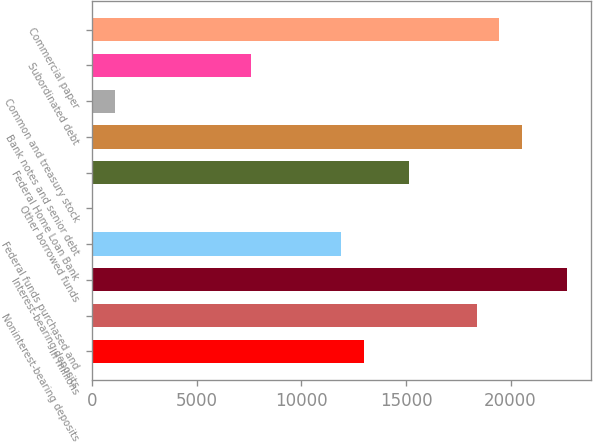Convert chart to OTSL. <chart><loc_0><loc_0><loc_500><loc_500><bar_chart><fcel>In millions<fcel>Noninterest-bearing deposits<fcel>Interest-bearing deposits<fcel>Federal funds purchased and<fcel>Other borrowed funds<fcel>Federal Home Loan Bank<fcel>Bank notes and senior debt<fcel>Common and treasury stock<fcel>Subordinated debt<fcel>Commercial paper<nl><fcel>12972.6<fcel>18374.1<fcel>22695.3<fcel>11892.3<fcel>9<fcel>15133.2<fcel>20534.7<fcel>1089.3<fcel>7571.1<fcel>19454.4<nl></chart> 